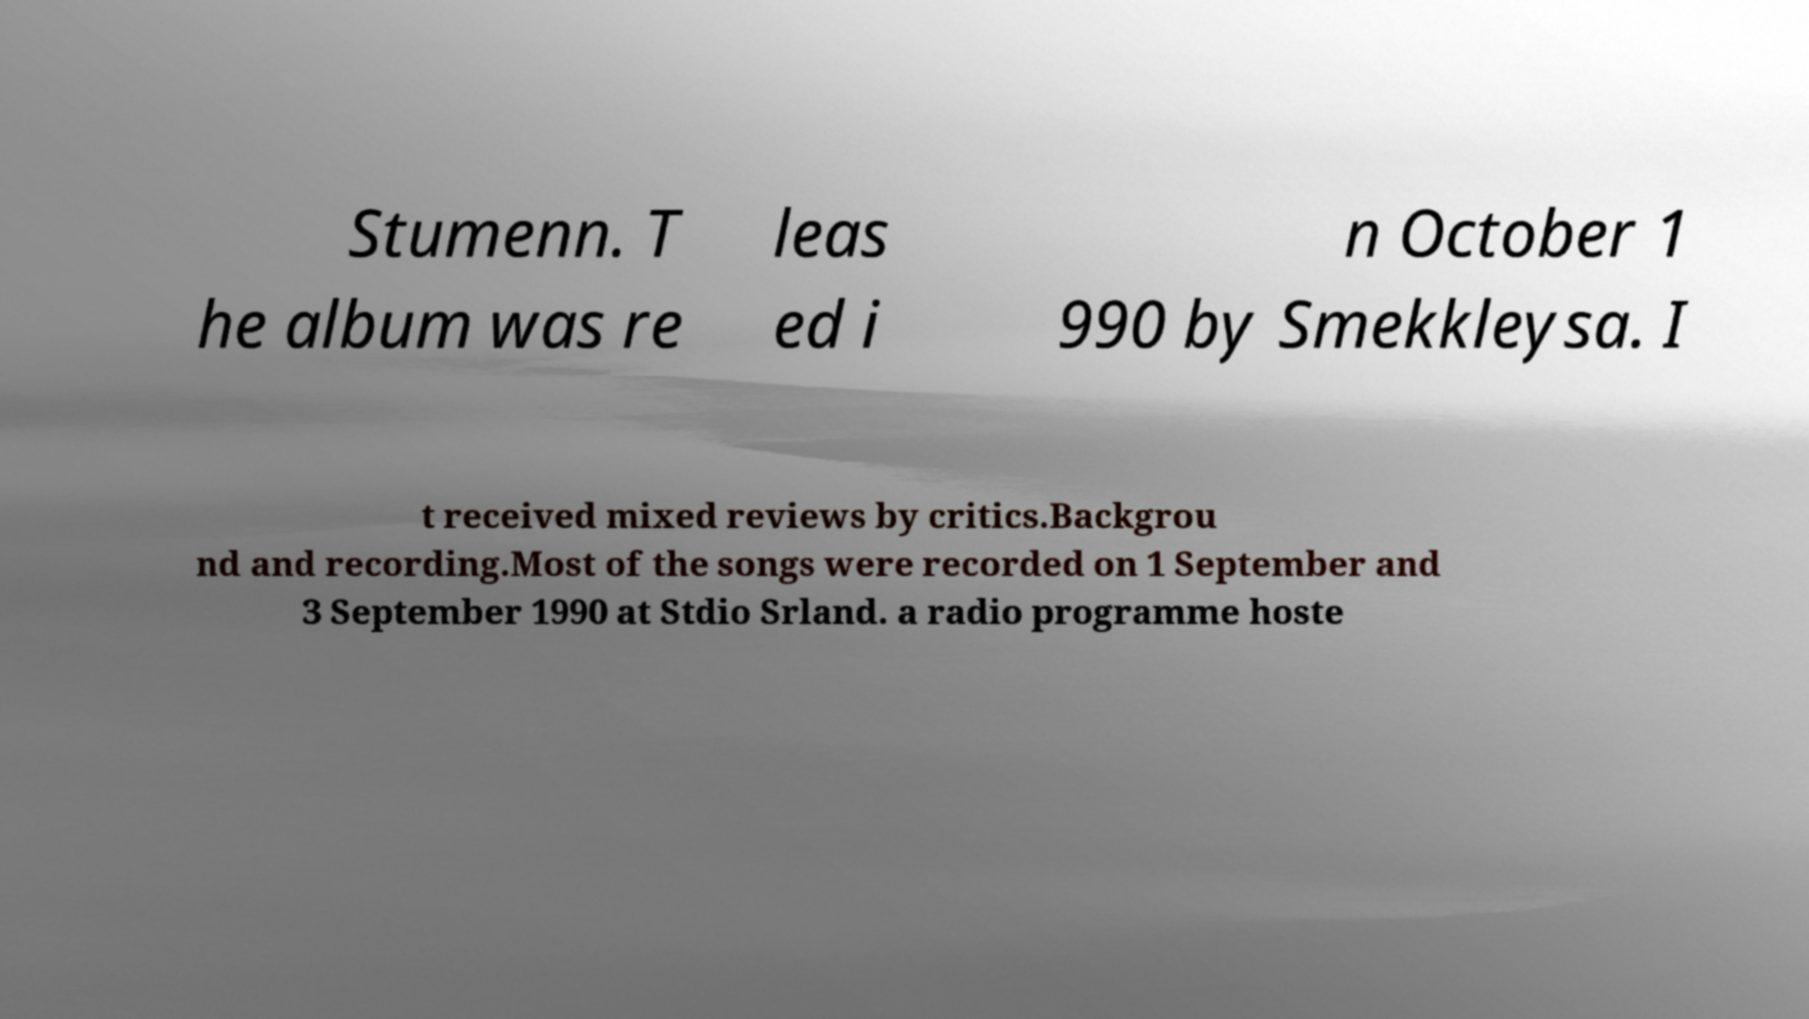Could you extract and type out the text from this image? Stumenn. T he album was re leas ed i n October 1 990 by Smekkleysa. I t received mixed reviews by critics.Backgrou nd and recording.Most of the songs were recorded on 1 September and 3 September 1990 at Stdio Srland. a radio programme hoste 